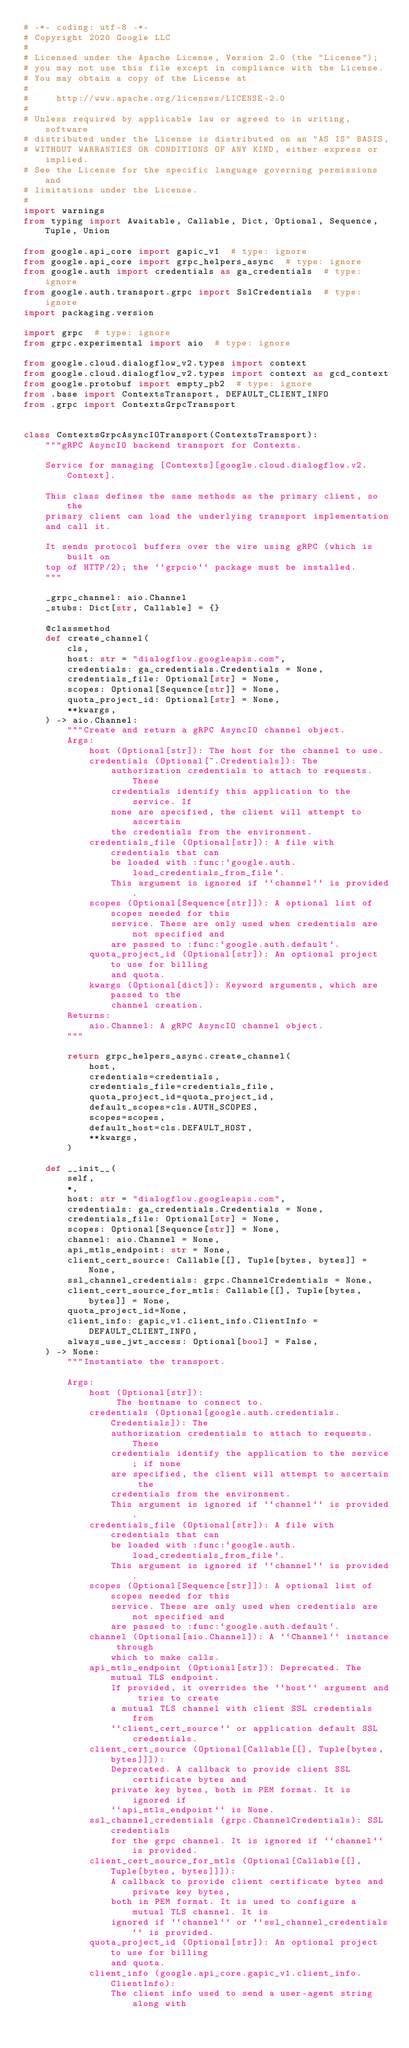Convert code to text. <code><loc_0><loc_0><loc_500><loc_500><_Python_># -*- coding: utf-8 -*-
# Copyright 2020 Google LLC
#
# Licensed under the Apache License, Version 2.0 (the "License");
# you may not use this file except in compliance with the License.
# You may obtain a copy of the License at
#
#     http://www.apache.org/licenses/LICENSE-2.0
#
# Unless required by applicable law or agreed to in writing, software
# distributed under the License is distributed on an "AS IS" BASIS,
# WITHOUT WARRANTIES OR CONDITIONS OF ANY KIND, either express or implied.
# See the License for the specific language governing permissions and
# limitations under the License.
#
import warnings
from typing import Awaitable, Callable, Dict, Optional, Sequence, Tuple, Union

from google.api_core import gapic_v1  # type: ignore
from google.api_core import grpc_helpers_async  # type: ignore
from google.auth import credentials as ga_credentials  # type: ignore
from google.auth.transport.grpc import SslCredentials  # type: ignore
import packaging.version

import grpc  # type: ignore
from grpc.experimental import aio  # type: ignore

from google.cloud.dialogflow_v2.types import context
from google.cloud.dialogflow_v2.types import context as gcd_context
from google.protobuf import empty_pb2  # type: ignore
from .base import ContextsTransport, DEFAULT_CLIENT_INFO
from .grpc import ContextsGrpcTransport


class ContextsGrpcAsyncIOTransport(ContextsTransport):
    """gRPC AsyncIO backend transport for Contexts.

    Service for managing [Contexts][google.cloud.dialogflow.v2.Context].

    This class defines the same methods as the primary client, so the
    primary client can load the underlying transport implementation
    and call it.

    It sends protocol buffers over the wire using gRPC (which is built on
    top of HTTP/2); the ``grpcio`` package must be installed.
    """

    _grpc_channel: aio.Channel
    _stubs: Dict[str, Callable] = {}

    @classmethod
    def create_channel(
        cls,
        host: str = "dialogflow.googleapis.com",
        credentials: ga_credentials.Credentials = None,
        credentials_file: Optional[str] = None,
        scopes: Optional[Sequence[str]] = None,
        quota_project_id: Optional[str] = None,
        **kwargs,
    ) -> aio.Channel:
        """Create and return a gRPC AsyncIO channel object.
        Args:
            host (Optional[str]): The host for the channel to use.
            credentials (Optional[~.Credentials]): The
                authorization credentials to attach to requests. These
                credentials identify this application to the service. If
                none are specified, the client will attempt to ascertain
                the credentials from the environment.
            credentials_file (Optional[str]): A file with credentials that can
                be loaded with :func:`google.auth.load_credentials_from_file`.
                This argument is ignored if ``channel`` is provided.
            scopes (Optional[Sequence[str]]): A optional list of scopes needed for this
                service. These are only used when credentials are not specified and
                are passed to :func:`google.auth.default`.
            quota_project_id (Optional[str]): An optional project to use for billing
                and quota.
            kwargs (Optional[dict]): Keyword arguments, which are passed to the
                channel creation.
        Returns:
            aio.Channel: A gRPC AsyncIO channel object.
        """

        return grpc_helpers_async.create_channel(
            host,
            credentials=credentials,
            credentials_file=credentials_file,
            quota_project_id=quota_project_id,
            default_scopes=cls.AUTH_SCOPES,
            scopes=scopes,
            default_host=cls.DEFAULT_HOST,
            **kwargs,
        )

    def __init__(
        self,
        *,
        host: str = "dialogflow.googleapis.com",
        credentials: ga_credentials.Credentials = None,
        credentials_file: Optional[str] = None,
        scopes: Optional[Sequence[str]] = None,
        channel: aio.Channel = None,
        api_mtls_endpoint: str = None,
        client_cert_source: Callable[[], Tuple[bytes, bytes]] = None,
        ssl_channel_credentials: grpc.ChannelCredentials = None,
        client_cert_source_for_mtls: Callable[[], Tuple[bytes, bytes]] = None,
        quota_project_id=None,
        client_info: gapic_v1.client_info.ClientInfo = DEFAULT_CLIENT_INFO,
        always_use_jwt_access: Optional[bool] = False,
    ) -> None:
        """Instantiate the transport.

        Args:
            host (Optional[str]):
                 The hostname to connect to.
            credentials (Optional[google.auth.credentials.Credentials]): The
                authorization credentials to attach to requests. These
                credentials identify the application to the service; if none
                are specified, the client will attempt to ascertain the
                credentials from the environment.
                This argument is ignored if ``channel`` is provided.
            credentials_file (Optional[str]): A file with credentials that can
                be loaded with :func:`google.auth.load_credentials_from_file`.
                This argument is ignored if ``channel`` is provided.
            scopes (Optional[Sequence[str]]): A optional list of scopes needed for this
                service. These are only used when credentials are not specified and
                are passed to :func:`google.auth.default`.
            channel (Optional[aio.Channel]): A ``Channel`` instance through
                which to make calls.
            api_mtls_endpoint (Optional[str]): Deprecated. The mutual TLS endpoint.
                If provided, it overrides the ``host`` argument and tries to create
                a mutual TLS channel with client SSL credentials from
                ``client_cert_source`` or application default SSL credentials.
            client_cert_source (Optional[Callable[[], Tuple[bytes, bytes]]]):
                Deprecated. A callback to provide client SSL certificate bytes and
                private key bytes, both in PEM format. It is ignored if
                ``api_mtls_endpoint`` is None.
            ssl_channel_credentials (grpc.ChannelCredentials): SSL credentials
                for the grpc channel. It is ignored if ``channel`` is provided.
            client_cert_source_for_mtls (Optional[Callable[[], Tuple[bytes, bytes]]]):
                A callback to provide client certificate bytes and private key bytes,
                both in PEM format. It is used to configure a mutual TLS channel. It is
                ignored if ``channel`` or ``ssl_channel_credentials`` is provided.
            quota_project_id (Optional[str]): An optional project to use for billing
                and quota.
            client_info (google.api_core.gapic_v1.client_info.ClientInfo):
                The client info used to send a user-agent string along with</code> 